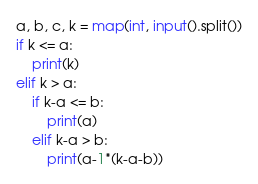<code> <loc_0><loc_0><loc_500><loc_500><_Python_>a, b, c, k = map(int, input().split())
if k <= a:
    print(k)
elif k > a:
    if k-a <= b:
        print(a)
    elif k-a > b:
        print(a-1*(k-a-b))</code> 